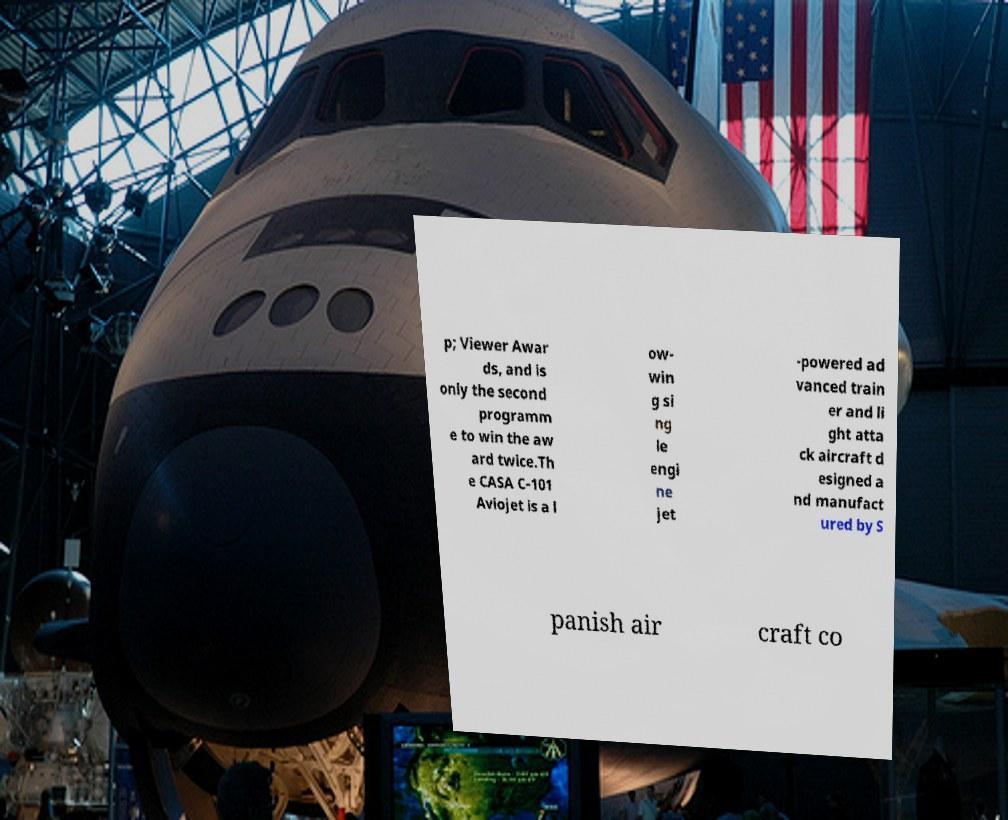For documentation purposes, I need the text within this image transcribed. Could you provide that? p; Viewer Awar ds, and is only the second programm e to win the aw ard twice.Th e CASA C-101 Aviojet is a l ow- win g si ng le engi ne jet -powered ad vanced train er and li ght atta ck aircraft d esigned a nd manufact ured by S panish air craft co 